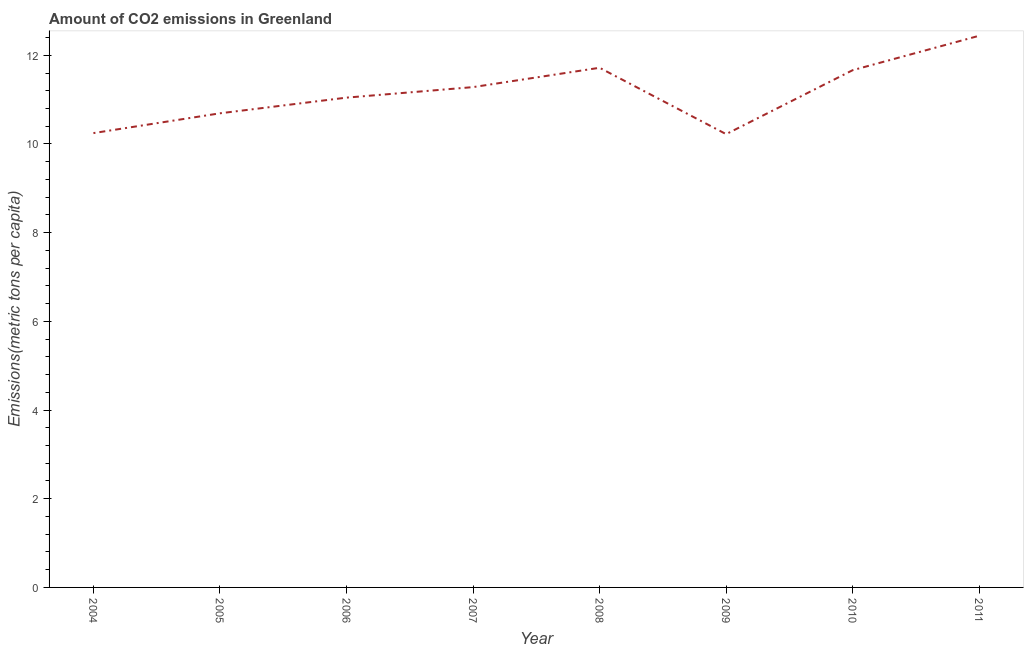What is the amount of co2 emissions in 2005?
Your response must be concise. 10.69. Across all years, what is the maximum amount of co2 emissions?
Offer a terse response. 12.44. Across all years, what is the minimum amount of co2 emissions?
Give a very brief answer. 10.22. In which year was the amount of co2 emissions minimum?
Give a very brief answer. 2009. What is the sum of the amount of co2 emissions?
Your answer should be compact. 89.31. What is the difference between the amount of co2 emissions in 2006 and 2008?
Provide a short and direct response. -0.67. What is the average amount of co2 emissions per year?
Keep it short and to the point. 11.16. What is the median amount of co2 emissions?
Your response must be concise. 11.16. Do a majority of the years between 2009 and 2011 (inclusive) have amount of co2 emissions greater than 8.8 metric tons per capita?
Offer a terse response. Yes. What is the ratio of the amount of co2 emissions in 2004 to that in 2006?
Keep it short and to the point. 0.93. What is the difference between the highest and the second highest amount of co2 emissions?
Keep it short and to the point. 0.72. Is the sum of the amount of co2 emissions in 2006 and 2010 greater than the maximum amount of co2 emissions across all years?
Your response must be concise. Yes. What is the difference between the highest and the lowest amount of co2 emissions?
Provide a succinct answer. 2.22. In how many years, is the amount of co2 emissions greater than the average amount of co2 emissions taken over all years?
Make the answer very short. 4. Does the amount of co2 emissions monotonically increase over the years?
Your response must be concise. No. How many lines are there?
Provide a succinct answer. 1. How many years are there in the graph?
Make the answer very short. 8. What is the difference between two consecutive major ticks on the Y-axis?
Offer a terse response. 2. Are the values on the major ticks of Y-axis written in scientific E-notation?
Your answer should be compact. No. Does the graph contain any zero values?
Keep it short and to the point. No. Does the graph contain grids?
Provide a succinct answer. No. What is the title of the graph?
Your response must be concise. Amount of CO2 emissions in Greenland. What is the label or title of the X-axis?
Provide a short and direct response. Year. What is the label or title of the Y-axis?
Give a very brief answer. Emissions(metric tons per capita). What is the Emissions(metric tons per capita) of 2004?
Your response must be concise. 10.24. What is the Emissions(metric tons per capita) in 2005?
Your response must be concise. 10.69. What is the Emissions(metric tons per capita) in 2006?
Your answer should be very brief. 11.04. What is the Emissions(metric tons per capita) in 2007?
Provide a succinct answer. 11.28. What is the Emissions(metric tons per capita) in 2008?
Offer a very short reply. 11.72. What is the Emissions(metric tons per capita) in 2009?
Make the answer very short. 10.22. What is the Emissions(metric tons per capita) in 2010?
Ensure brevity in your answer.  11.66. What is the Emissions(metric tons per capita) in 2011?
Give a very brief answer. 12.44. What is the difference between the Emissions(metric tons per capita) in 2004 and 2005?
Offer a terse response. -0.45. What is the difference between the Emissions(metric tons per capita) in 2004 and 2006?
Your answer should be compact. -0.8. What is the difference between the Emissions(metric tons per capita) in 2004 and 2007?
Your answer should be compact. -1.04. What is the difference between the Emissions(metric tons per capita) in 2004 and 2008?
Your answer should be very brief. -1.47. What is the difference between the Emissions(metric tons per capita) in 2004 and 2009?
Offer a terse response. 0.02. What is the difference between the Emissions(metric tons per capita) in 2004 and 2010?
Ensure brevity in your answer.  -1.42. What is the difference between the Emissions(metric tons per capita) in 2004 and 2011?
Your answer should be compact. -2.2. What is the difference between the Emissions(metric tons per capita) in 2005 and 2006?
Your answer should be very brief. -0.35. What is the difference between the Emissions(metric tons per capita) in 2005 and 2007?
Offer a very short reply. -0.59. What is the difference between the Emissions(metric tons per capita) in 2005 and 2008?
Offer a terse response. -1.03. What is the difference between the Emissions(metric tons per capita) in 2005 and 2009?
Provide a short and direct response. 0.47. What is the difference between the Emissions(metric tons per capita) in 2005 and 2010?
Provide a succinct answer. -0.97. What is the difference between the Emissions(metric tons per capita) in 2005 and 2011?
Offer a terse response. -1.75. What is the difference between the Emissions(metric tons per capita) in 2006 and 2007?
Keep it short and to the point. -0.24. What is the difference between the Emissions(metric tons per capita) in 2006 and 2008?
Provide a succinct answer. -0.67. What is the difference between the Emissions(metric tons per capita) in 2006 and 2009?
Keep it short and to the point. 0.82. What is the difference between the Emissions(metric tons per capita) in 2006 and 2010?
Provide a succinct answer. -0.62. What is the difference between the Emissions(metric tons per capita) in 2006 and 2011?
Provide a succinct answer. -1.4. What is the difference between the Emissions(metric tons per capita) in 2007 and 2008?
Provide a succinct answer. -0.44. What is the difference between the Emissions(metric tons per capita) in 2007 and 2009?
Offer a terse response. 1.06. What is the difference between the Emissions(metric tons per capita) in 2007 and 2010?
Give a very brief answer. -0.38. What is the difference between the Emissions(metric tons per capita) in 2007 and 2011?
Your answer should be compact. -1.16. What is the difference between the Emissions(metric tons per capita) in 2008 and 2009?
Offer a terse response. 1.5. What is the difference between the Emissions(metric tons per capita) in 2008 and 2010?
Give a very brief answer. 0.05. What is the difference between the Emissions(metric tons per capita) in 2008 and 2011?
Ensure brevity in your answer.  -0.72. What is the difference between the Emissions(metric tons per capita) in 2009 and 2010?
Provide a short and direct response. -1.44. What is the difference between the Emissions(metric tons per capita) in 2009 and 2011?
Provide a short and direct response. -2.22. What is the difference between the Emissions(metric tons per capita) in 2010 and 2011?
Your response must be concise. -0.78. What is the ratio of the Emissions(metric tons per capita) in 2004 to that in 2005?
Your response must be concise. 0.96. What is the ratio of the Emissions(metric tons per capita) in 2004 to that in 2006?
Your answer should be very brief. 0.93. What is the ratio of the Emissions(metric tons per capita) in 2004 to that in 2007?
Your response must be concise. 0.91. What is the ratio of the Emissions(metric tons per capita) in 2004 to that in 2008?
Your answer should be compact. 0.87. What is the ratio of the Emissions(metric tons per capita) in 2004 to that in 2010?
Provide a short and direct response. 0.88. What is the ratio of the Emissions(metric tons per capita) in 2004 to that in 2011?
Keep it short and to the point. 0.82. What is the ratio of the Emissions(metric tons per capita) in 2005 to that in 2006?
Make the answer very short. 0.97. What is the ratio of the Emissions(metric tons per capita) in 2005 to that in 2007?
Your response must be concise. 0.95. What is the ratio of the Emissions(metric tons per capita) in 2005 to that in 2008?
Offer a very short reply. 0.91. What is the ratio of the Emissions(metric tons per capita) in 2005 to that in 2009?
Provide a succinct answer. 1.05. What is the ratio of the Emissions(metric tons per capita) in 2005 to that in 2010?
Give a very brief answer. 0.92. What is the ratio of the Emissions(metric tons per capita) in 2005 to that in 2011?
Provide a succinct answer. 0.86. What is the ratio of the Emissions(metric tons per capita) in 2006 to that in 2008?
Provide a succinct answer. 0.94. What is the ratio of the Emissions(metric tons per capita) in 2006 to that in 2009?
Offer a terse response. 1.08. What is the ratio of the Emissions(metric tons per capita) in 2006 to that in 2010?
Offer a very short reply. 0.95. What is the ratio of the Emissions(metric tons per capita) in 2006 to that in 2011?
Your answer should be compact. 0.89. What is the ratio of the Emissions(metric tons per capita) in 2007 to that in 2009?
Keep it short and to the point. 1.1. What is the ratio of the Emissions(metric tons per capita) in 2007 to that in 2010?
Offer a terse response. 0.97. What is the ratio of the Emissions(metric tons per capita) in 2007 to that in 2011?
Offer a very short reply. 0.91. What is the ratio of the Emissions(metric tons per capita) in 2008 to that in 2009?
Keep it short and to the point. 1.15. What is the ratio of the Emissions(metric tons per capita) in 2008 to that in 2011?
Provide a succinct answer. 0.94. What is the ratio of the Emissions(metric tons per capita) in 2009 to that in 2010?
Keep it short and to the point. 0.88. What is the ratio of the Emissions(metric tons per capita) in 2009 to that in 2011?
Give a very brief answer. 0.82. What is the ratio of the Emissions(metric tons per capita) in 2010 to that in 2011?
Keep it short and to the point. 0.94. 